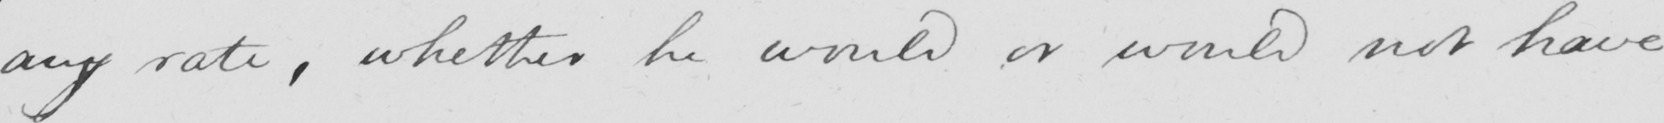Can you tell me what this handwritten text says? any rate , whether he would or would not have 